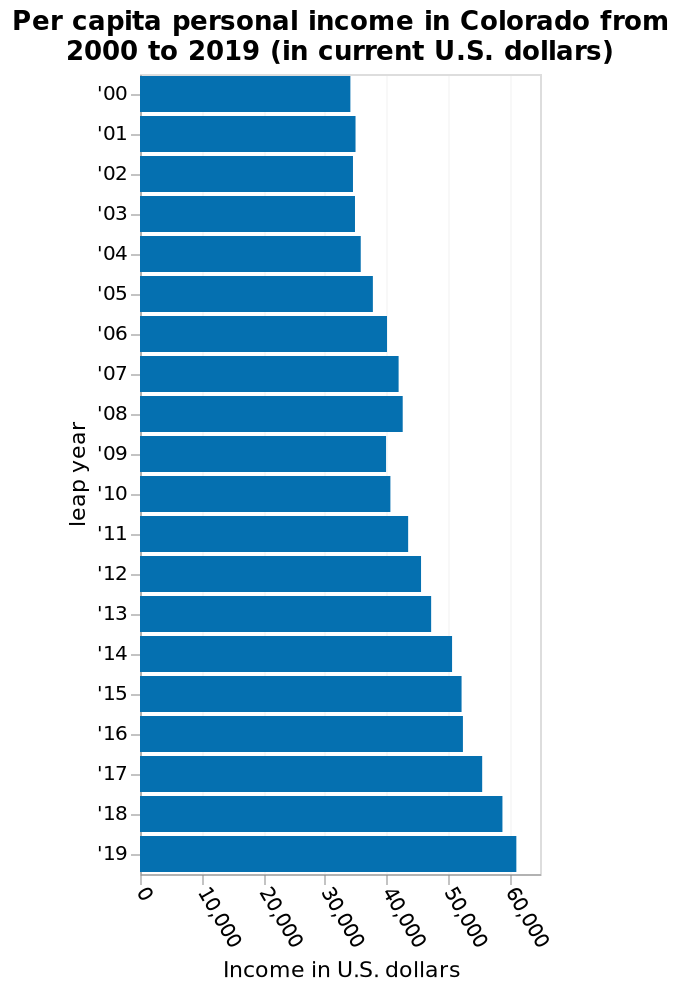<image>
What was the year with the highest per capita personal income in Colorado?  The year with the highest per capita personal income in Colorado is 2019. Has per capita personal income in Colorado increased or decreased between 2000 and 2019?  Per capita personal income in Colorado has increased between 2000 and 2019. How does per capita personal income in Colorado compare between the years 2000 and 2019? Per capita personal income in Colorado has increased between the years 2000 and 2019. 